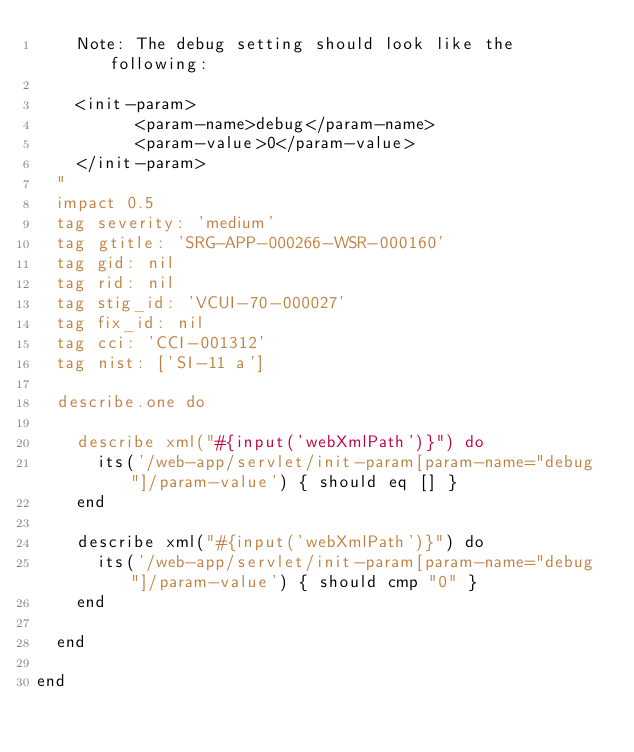<code> <loc_0><loc_0><loc_500><loc_500><_Ruby_>    Note: The debug setting should look like the following:

    <init-param>
          <param-name>debug</param-name>
          <param-value>0</param-value>
    </init-param>
  "
  impact 0.5
  tag severity: 'medium'
  tag gtitle: 'SRG-APP-000266-WSR-000160'
  tag gid: nil
  tag rid: nil
  tag stig_id: 'VCUI-70-000027'
  tag fix_id: nil
  tag cci: 'CCI-001312'
  tag nist: ['SI-11 a']

  describe.one do

    describe xml("#{input('webXmlPath')}") do
      its('/web-app/servlet/init-param[param-name="debug"]/param-value') { should eq [] }
    end

    describe xml("#{input('webXmlPath')}") do
      its('/web-app/servlet/init-param[param-name="debug"]/param-value') { should cmp "0" }
    end

  end

end

</code> 